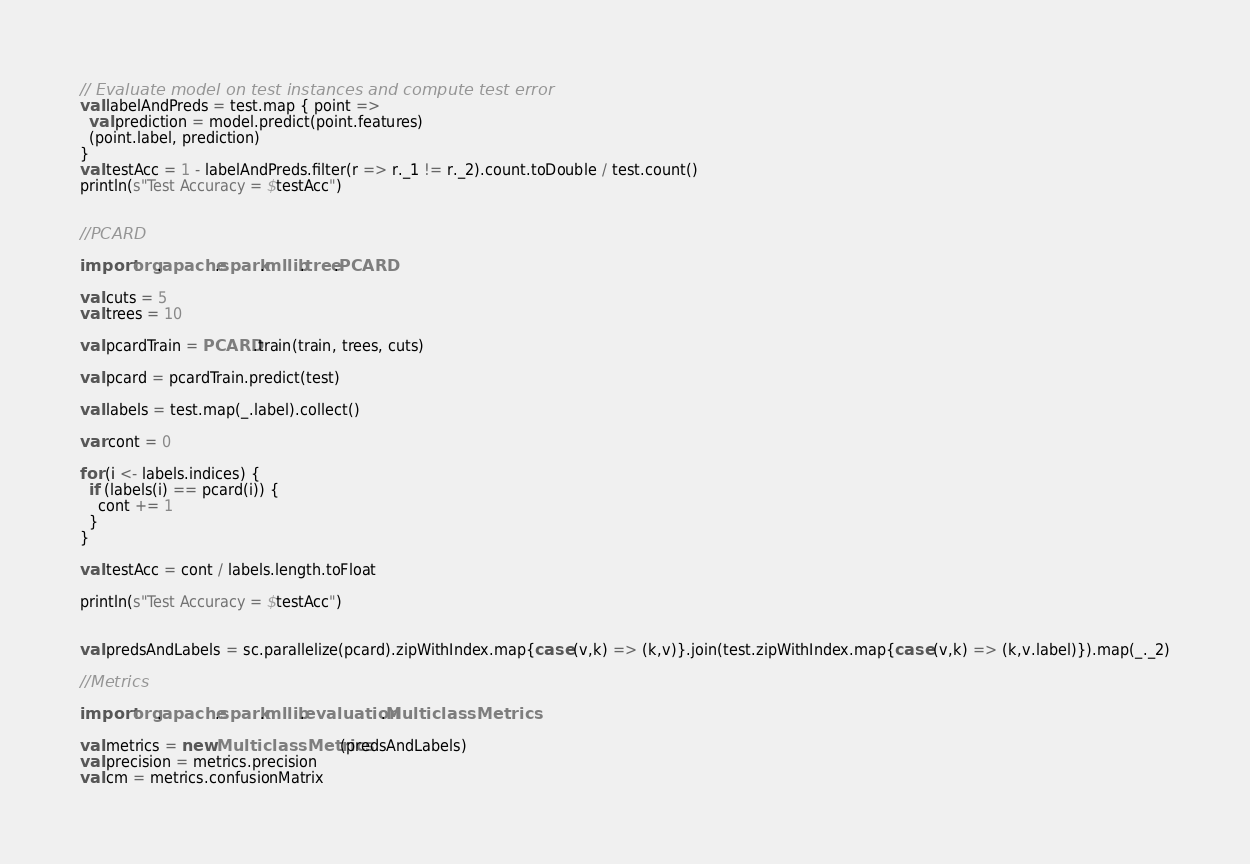Convert code to text. <code><loc_0><loc_0><loc_500><loc_500><_Scala_>
// Evaluate model on test instances and compute test error
val labelAndPreds = test.map { point =>
  val prediction = model.predict(point.features)
  (point.label, prediction)
}
val testAcc = 1 - labelAndPreds.filter(r => r._1 != r._2).count.toDouble / test.count()
println(s"Test Accuracy = $testAcc")


//PCARD

import org.apache.spark.mllib.tree.PCARD

val cuts = 5
val trees = 10

val pcardTrain = PCARD.train(train, trees, cuts)

val pcard = pcardTrain.predict(test)

val labels = test.map(_.label).collect()

var cont = 0

for (i <- labels.indices) {
  if (labels(i) == pcard(i)) {
    cont += 1
  }
}

val testAcc = cont / labels.length.toFloat

println(s"Test Accuracy = $testAcc")


val predsAndLabels = sc.parallelize(pcard).zipWithIndex.map{case (v,k) => (k,v)}.join(test.zipWithIndex.map{case (v,k) => (k,v.label)}).map(_._2)

//Metrics

import org.apache.spark.mllib.evaluation.MulticlassMetrics

val metrics = new MulticlassMetrics(predsAndLabels)
val precision = metrics.precision
val cm = metrics.confusionMatrix
</code> 